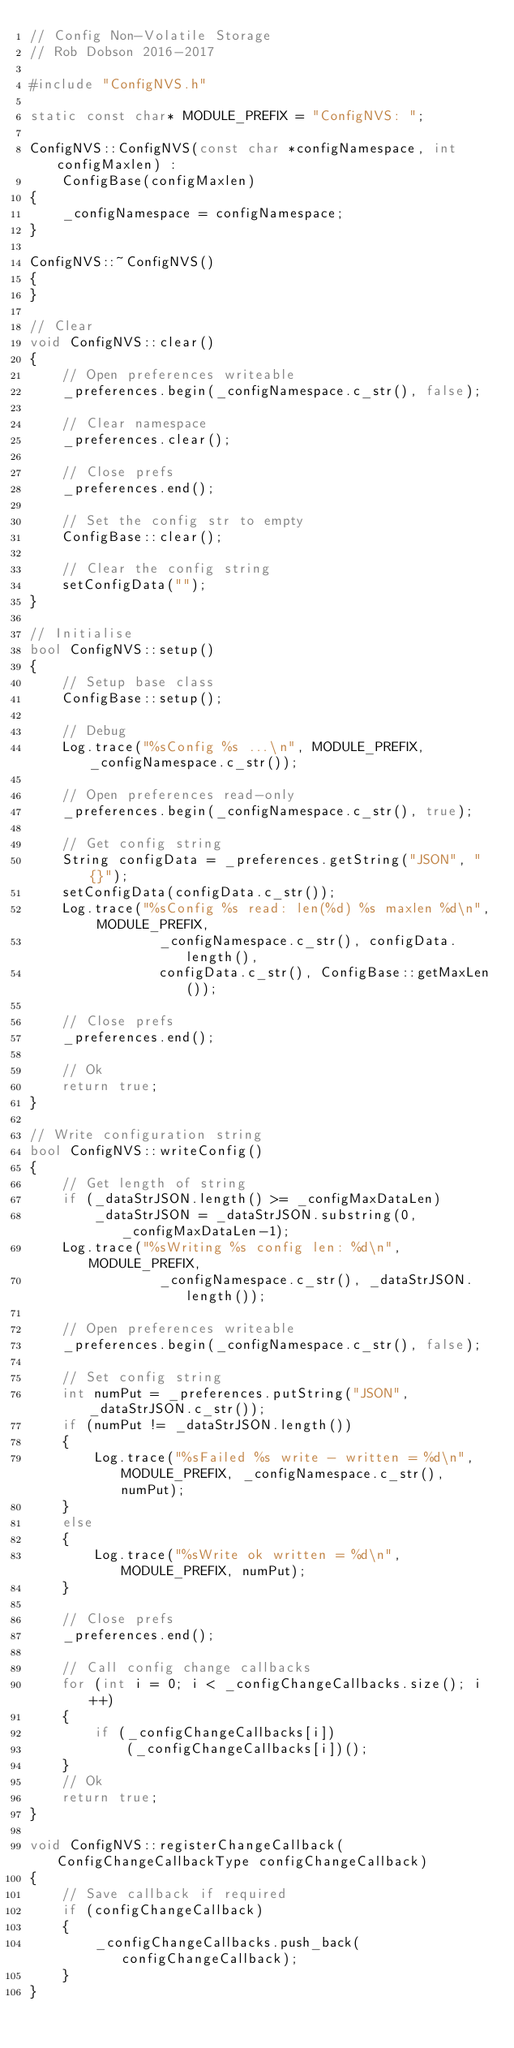Convert code to text. <code><loc_0><loc_0><loc_500><loc_500><_C++_>// Config Non-Volatile Storage
// Rob Dobson 2016-2017

#include "ConfigNVS.h"

static const char* MODULE_PREFIX = "ConfigNVS: ";

ConfigNVS::ConfigNVS(const char *configNamespace, int configMaxlen) :
    ConfigBase(configMaxlen)
{
    _configNamespace = configNamespace;
}

ConfigNVS::~ConfigNVS()
{
}

// Clear
void ConfigNVS::clear()
{
    // Open preferences writeable
    _preferences.begin(_configNamespace.c_str(), false);

    // Clear namespace
    _preferences.clear();

    // Close prefs
    _preferences.end();

    // Set the config str to empty
    ConfigBase::clear();

    // Clear the config string
    setConfigData("");
}

// Initialise
bool ConfigNVS::setup()
{
    // Setup base class
    ConfigBase::setup();

    // Debug
    Log.trace("%sConfig %s ...\n", MODULE_PREFIX, _configNamespace.c_str());

    // Open preferences read-only
    _preferences.begin(_configNamespace.c_str(), true);

    // Get config string
    String configData = _preferences.getString("JSON", "{}");
    setConfigData(configData.c_str());
    Log.trace("%sConfig %s read: len(%d) %s maxlen %d\n", MODULE_PREFIX, 
                _configNamespace.c_str(), configData.length(), 
                configData.c_str(), ConfigBase::getMaxLen());

    // Close prefs
    _preferences.end();

    // Ok
    return true;
}

// Write configuration string
bool ConfigNVS::writeConfig()
{
    // Get length of string
    if (_dataStrJSON.length() >= _configMaxDataLen)
        _dataStrJSON = _dataStrJSON.substring(0, _configMaxDataLen-1);
    Log.trace("%sWriting %s config len: %d\n", MODULE_PREFIX, 
                _configNamespace.c_str(), _dataStrJSON.length());

    // Open preferences writeable
    _preferences.begin(_configNamespace.c_str(), false);

    // Set config string
    int numPut = _preferences.putString("JSON", _dataStrJSON.c_str());
    if (numPut != _dataStrJSON.length())
    {
        Log.trace("%sFailed %s write - written = %d\n", MODULE_PREFIX, _configNamespace.c_str(), numPut);
    }
    else
    {
        Log.trace("%sWrite ok written = %d\n", MODULE_PREFIX, numPut);
    }

    // Close prefs
    _preferences.end();

    // Call config change callbacks
    for (int i = 0; i < _configChangeCallbacks.size(); i++)
    {
        if (_configChangeCallbacks[i])
            (_configChangeCallbacks[i])();
    }
    // Ok
    return true;
}

void ConfigNVS::registerChangeCallback(ConfigChangeCallbackType configChangeCallback)
{
    // Save callback if required
    if (configChangeCallback)
    {
        _configChangeCallbacks.push_back(configChangeCallback);
    }
}</code> 